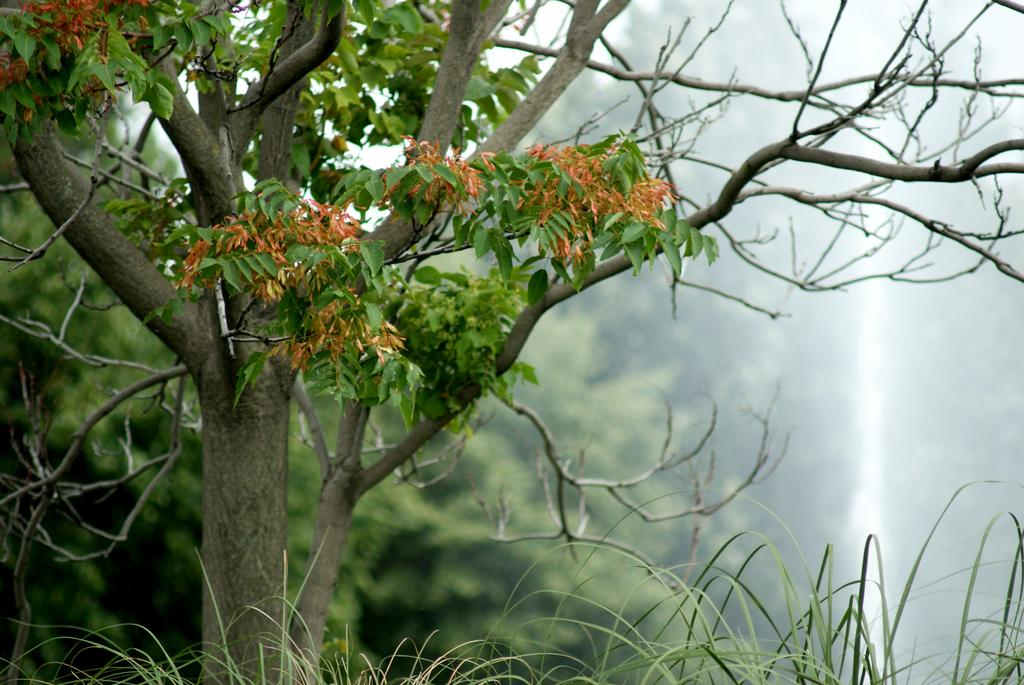What type of vegetation can be seen in the image? There are trees in the image. What color are some of the leaves on the trees? Some of the leaves on the trees are red. What type of mitten is hanging on the tree in the image? There is no mitten present in the image; it only features trees with red leaves. 